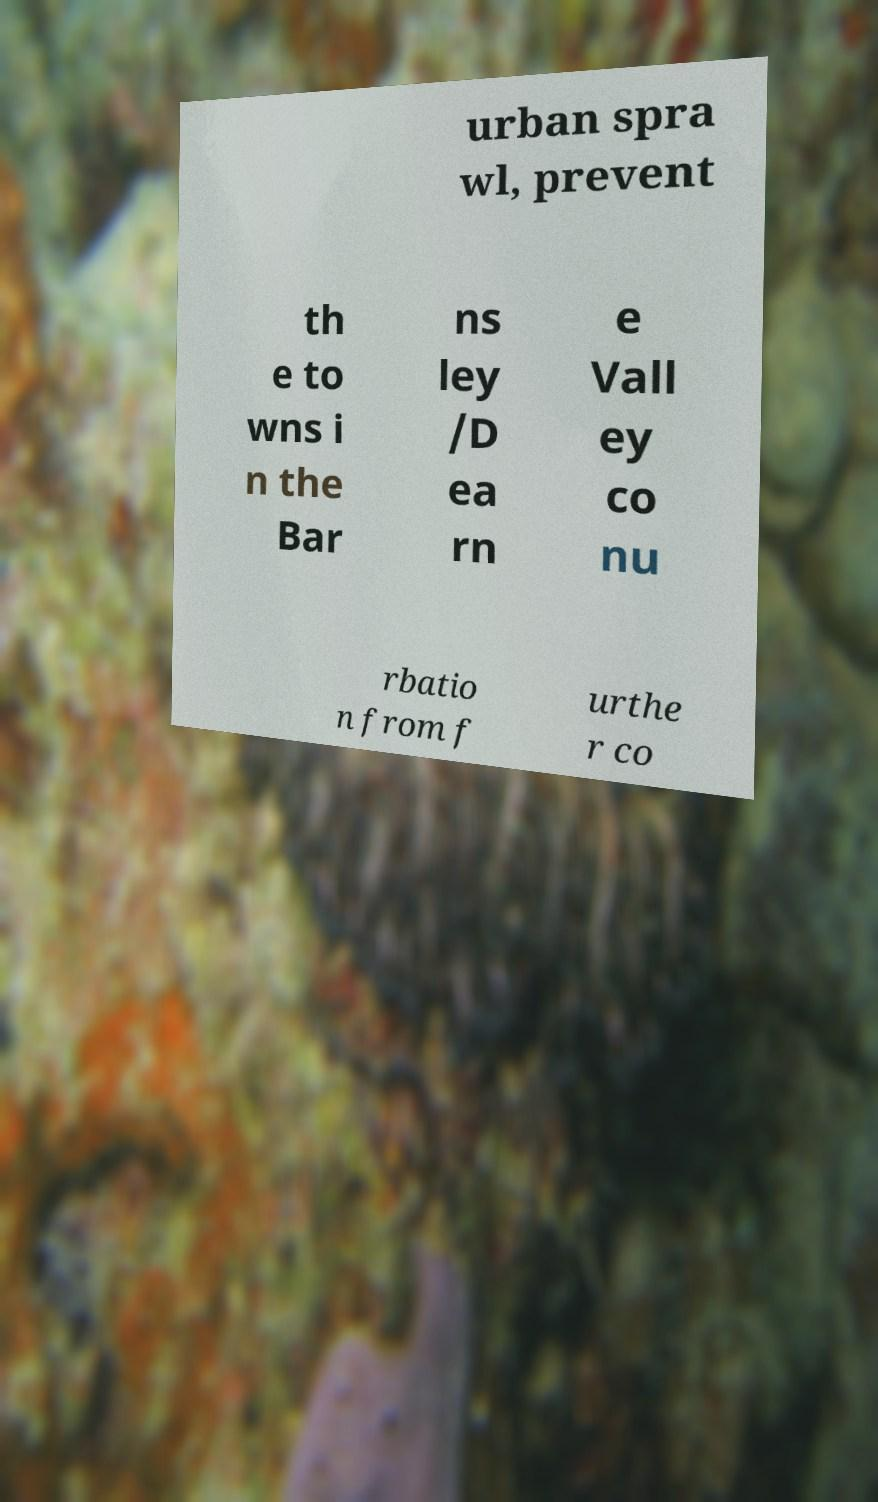There's text embedded in this image that I need extracted. Can you transcribe it verbatim? urban spra wl, prevent th e to wns i n the Bar ns ley /D ea rn e Vall ey co nu rbatio n from f urthe r co 